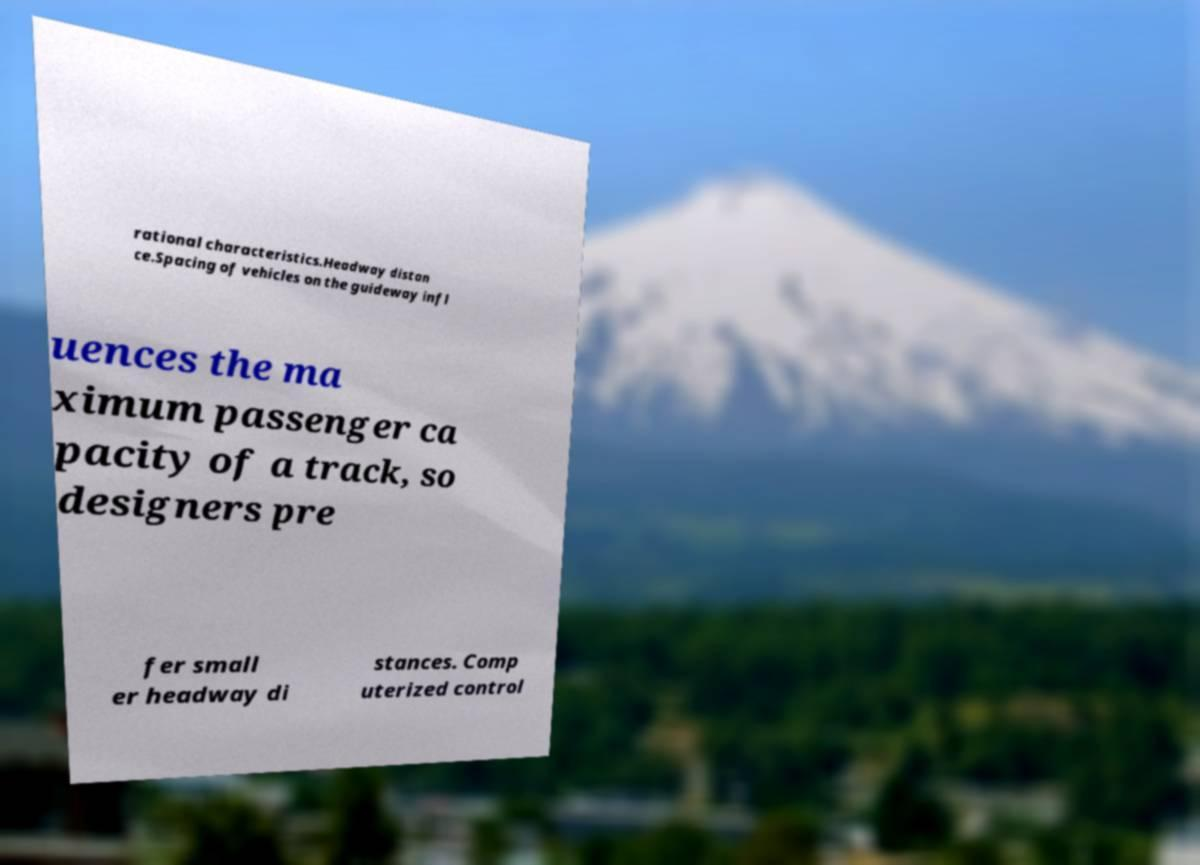What messages or text are displayed in this image? I need them in a readable, typed format. rational characteristics.Headway distan ce.Spacing of vehicles on the guideway infl uences the ma ximum passenger ca pacity of a track, so designers pre fer small er headway di stances. Comp uterized control 